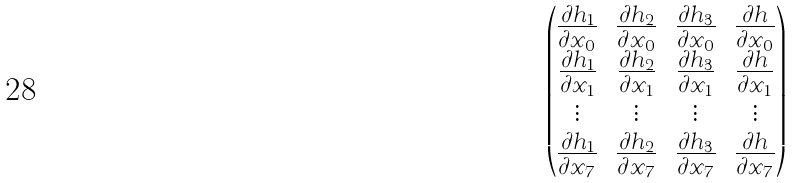Convert formula to latex. <formula><loc_0><loc_0><loc_500><loc_500>\begin{pmatrix} \frac { \partial h _ { 1 } } { \partial x _ { 0 } } & \frac { \partial h _ { 2 } } { \partial x _ { 0 } } & \frac { \partial h _ { 3 } } { \partial x _ { 0 } } & \frac { \partial h } { \partial x _ { 0 } } \\ \frac { \partial h _ { 1 } } { \partial x _ { 1 } } & \frac { \partial h _ { 2 } } { \partial x _ { 1 } } & \frac { \partial h _ { 3 } } { \partial x _ { 1 } } & \frac { \partial h } { \partial x _ { 1 } } \\ \vdots & \vdots & \vdots & \vdots \\ \frac { \partial h _ { 1 } } { \partial x _ { 7 } } & \frac { \partial h _ { 2 } } { \partial x _ { 7 } } & \frac { \partial h _ { 3 } } { \partial x _ { 7 } } & \frac { \partial h } { \partial x _ { 7 } } \\ \end{pmatrix}</formula> 